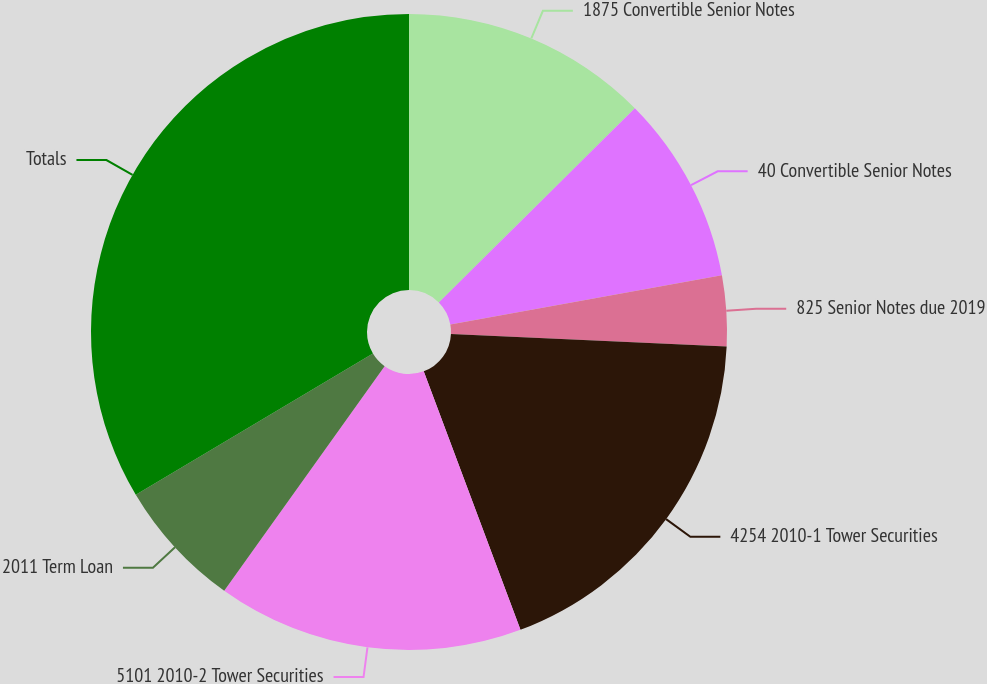Convert chart. <chart><loc_0><loc_0><loc_500><loc_500><pie_chart><fcel>1875 Convertible Senior Notes<fcel>40 Convertible Senior Notes<fcel>825 Senior Notes due 2019<fcel>4254 2010-1 Tower Securities<fcel>5101 2010-2 Tower Securities<fcel>2011 Term Loan<fcel>Totals<nl><fcel>12.57%<fcel>9.58%<fcel>3.58%<fcel>18.57%<fcel>15.57%<fcel>6.58%<fcel>33.55%<nl></chart> 